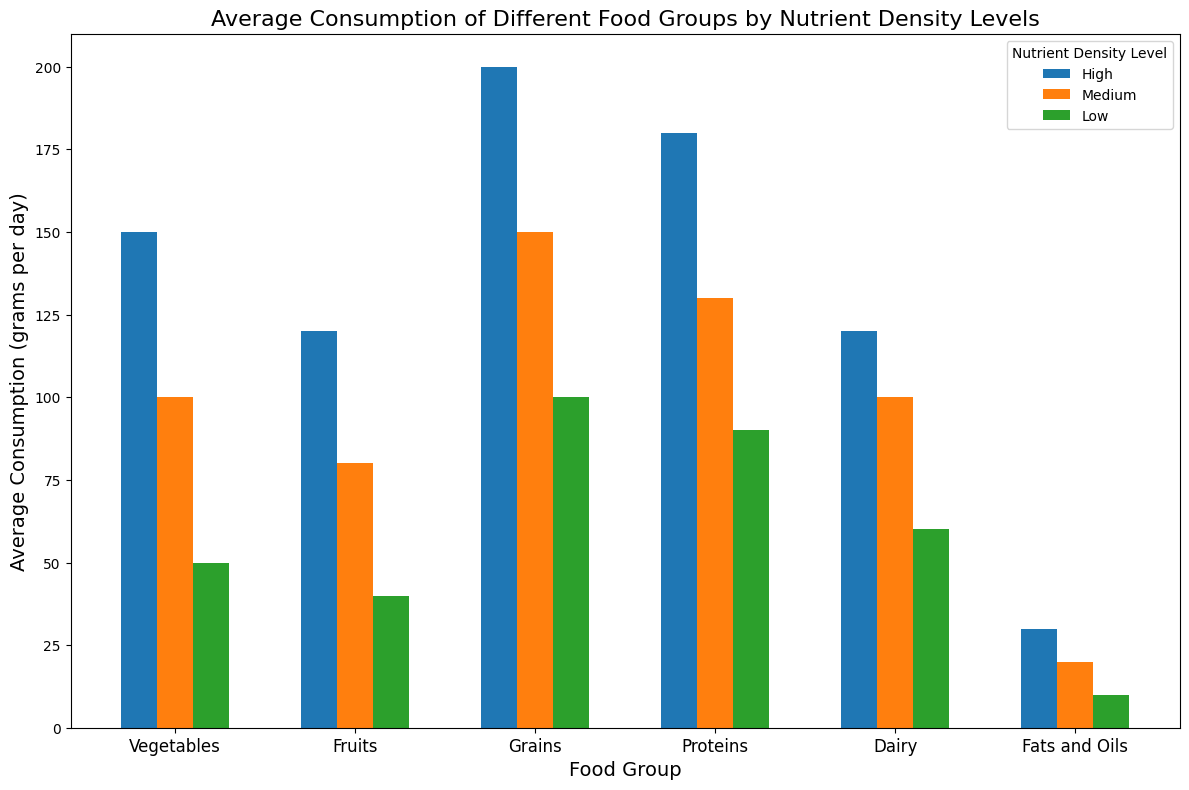What is the food group with the highest average consumption at high nutrient density? The data shows bars for different food groups' average consumption at each nutrient density level. For high nutrient density, the tallest bar represents grains with 200 grams per day.
Answer: Grains Which food group has the lowest average consumption at low nutrient density? Observing the bars for low nutrient density levels, fats and oils have the shortest bar, representing an average consumption of 10 grams per day.
Answer: Fats and Oils What is the difference in average consumption between high and low nutrient density for vegetables? For vegetables, the average consumption at high nutrient density is 150 grams per day, and at low nutrient density, it is 50 grams per day. The difference is 150 - 50.
Answer: 100 grams per day Compare the average consumption of 'Fruits' at medium and low nutrient density levels. Looking at the bars for fruits, the average consumption at medium nutrient density is 80 grams per day, while at low nutrient density, it is 40 grams per day. The medium density is higher.
Answer: Medium is higher How much more grains are consumed compared to the average consumption of dairy at high nutrient density levels? At high nutrient density, the average consumption of grains is 200 grams per day, and dairy is 120 grams per day. The difference is 200 - 120.
Answer: 80 grams per day Determine the total average consumption of proteins across all nutrient density levels. Summing up the average consumption of proteins at high (180 grams), medium (130 grams), and low (90 grams) nutrient density: 180 + 130 + 90 equals 400 grams.
Answer: 400 grams per day Identify the nutrient density level with the least average consumption for proteins compared to vegetables at the same level. Comparing each nutrient density level, for proteins, the low nutrient density consumption is 90 grams, and for vegetables, it is 50 grams. Therefore, vegetables at low nutrient density have the least average consumption.
Answer: Vegetables at low nutrient density What is the average consumption of food groups by combining all data for medium nutrient density levels? Summing up the average consumption at medium nutrient density for each food group: Vegetables (100) + Fruits (80) + Grains (150) + Proteins (130) + Dairy (100) + Fats and Oils (20) = 580 grams.
Answer: 580 grams per day 